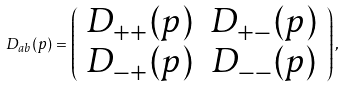Convert formula to latex. <formula><loc_0><loc_0><loc_500><loc_500>D _ { a b } ( p ) = \left ( \begin{array} { c c } D _ { + + } ( p ) & D _ { + - } ( p ) \\ D _ { - + } ( p ) & D _ { - - } ( p ) \end{array} \right ) ,</formula> 